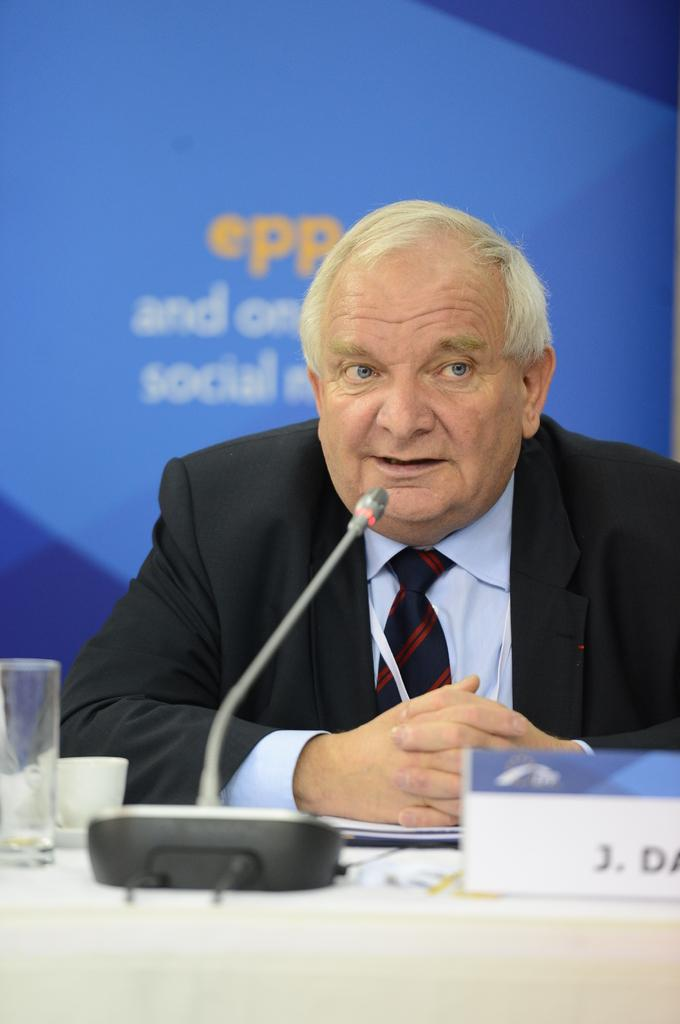Who or what is in the image? There is a person in the image. What is in front of the person? There is a table in front of the person. What is on top of the table? There is a name board on top of the table. What else is on the table? There is a microphone (mike) on the table. What else can be seen on the table? There is a glass and a cup on the table. What is visible behind the person? There is a banner behind the person. What type of vein is visible on the person's arm in the image? There is no visible vein on the person's arm in the image. What brand of toothpaste is advertised on the banner behind the person? There is no toothpaste or brand mentioned on the banner in the image. 